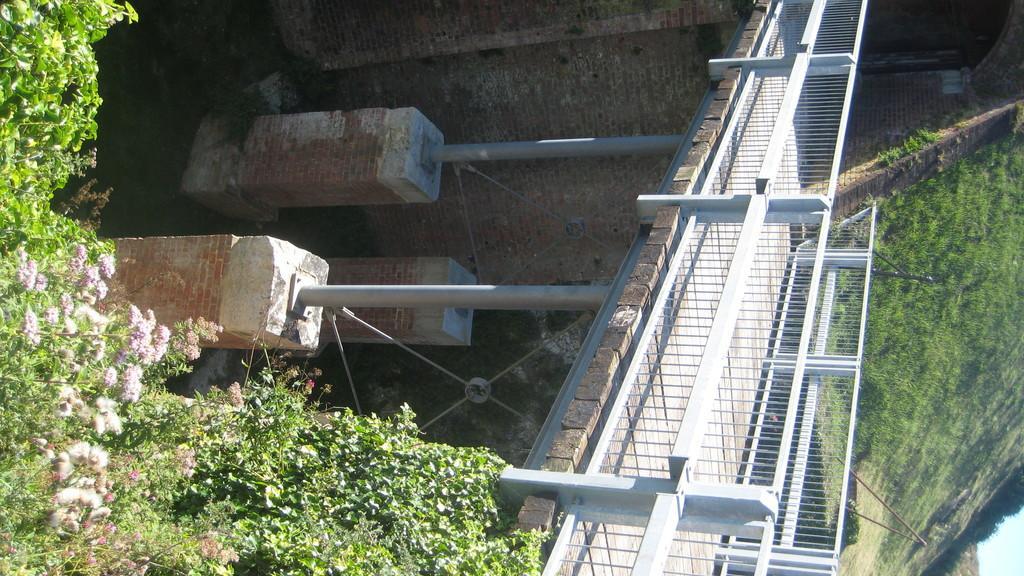Can you describe this image briefly? In this image I can see there is a bridge on the right side with a railing, there are pillars and there are plants with flowers and there are trees. 